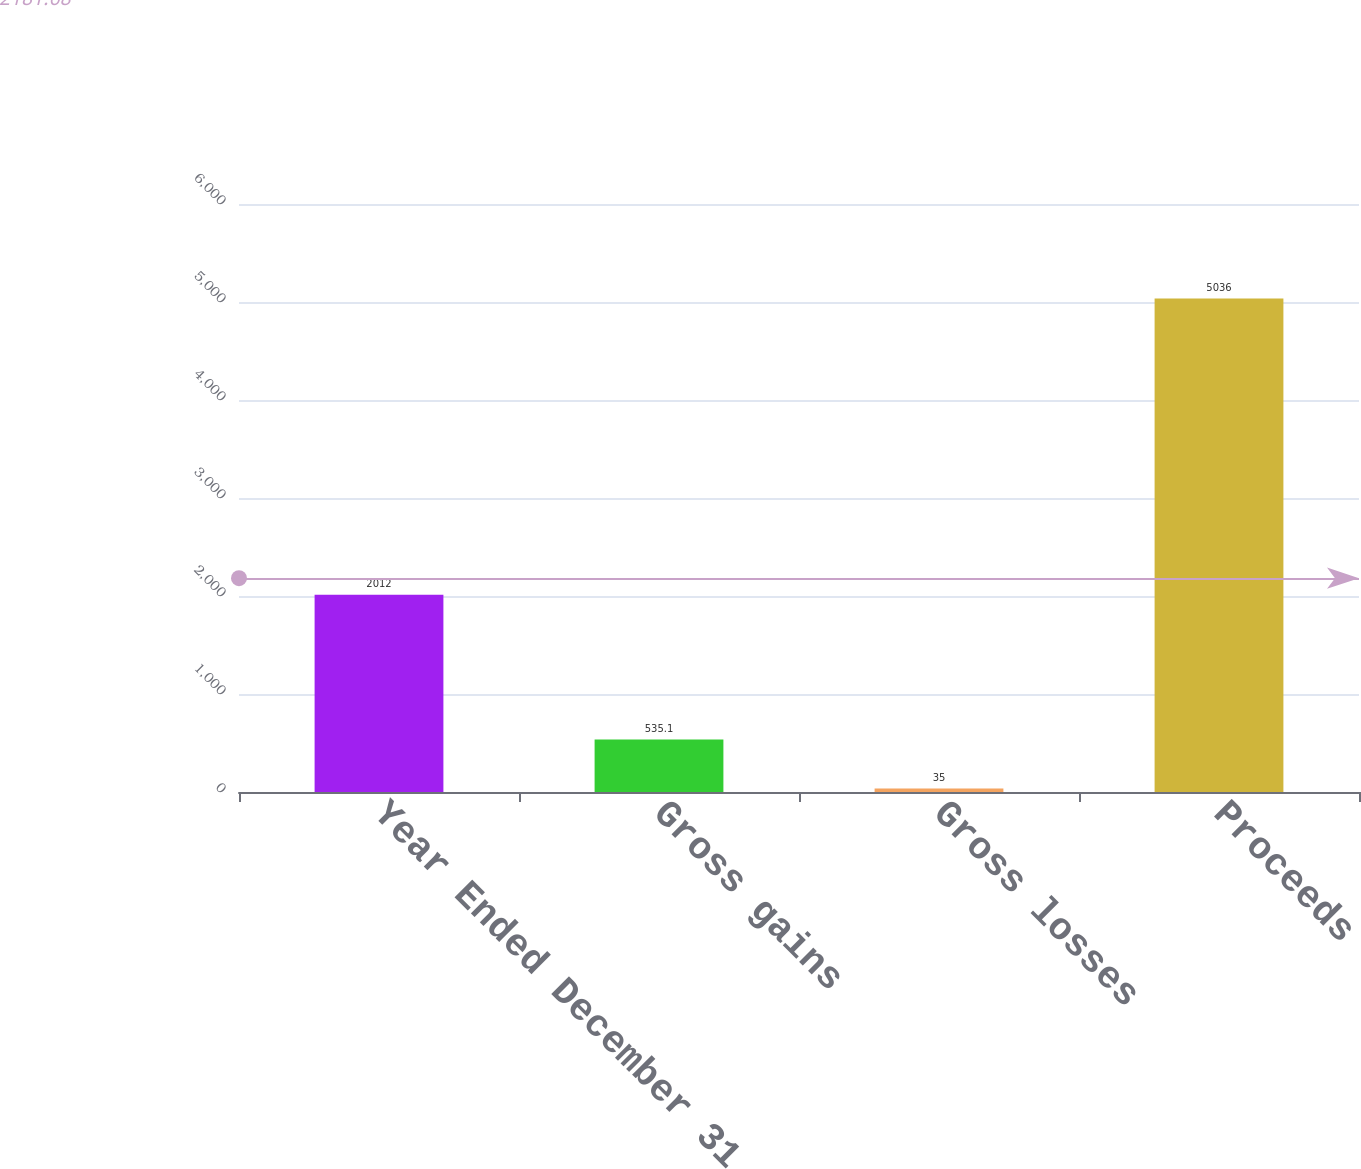Convert chart to OTSL. <chart><loc_0><loc_0><loc_500><loc_500><bar_chart><fcel>Year Ended December 31<fcel>Gross gains<fcel>Gross losses<fcel>Proceeds<nl><fcel>2012<fcel>535.1<fcel>35<fcel>5036<nl></chart> 